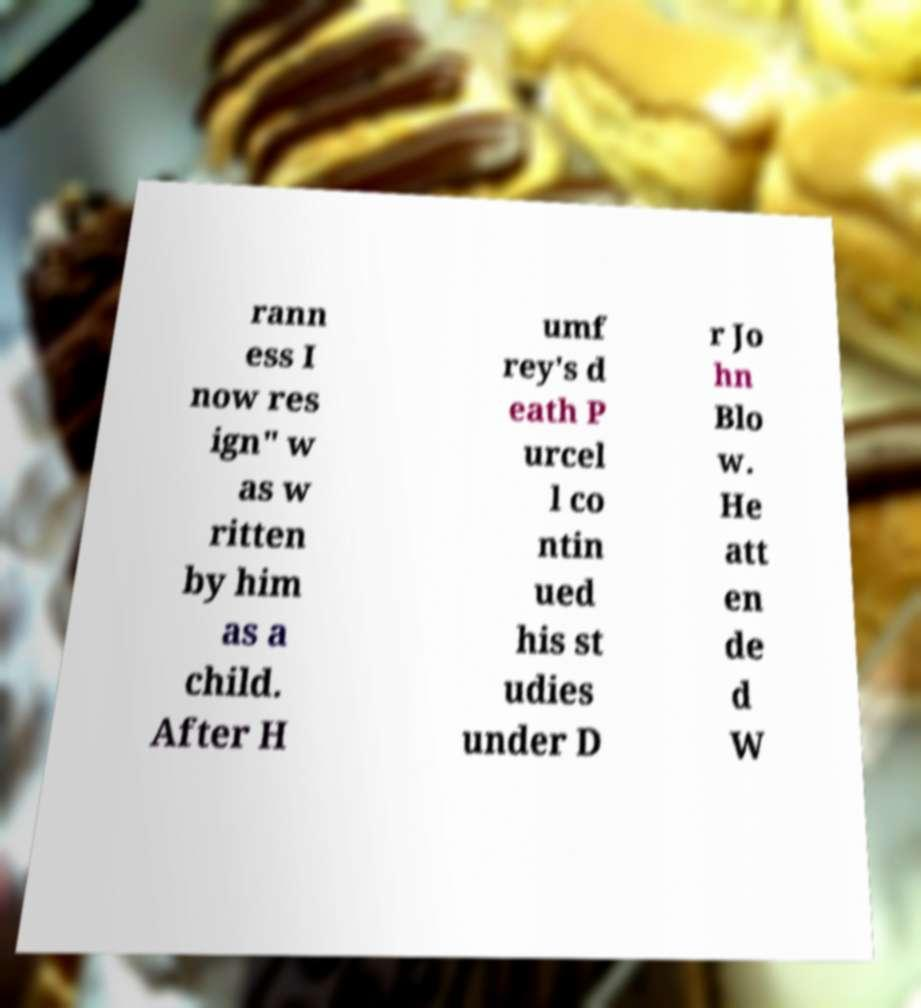Could you assist in decoding the text presented in this image and type it out clearly? rann ess I now res ign" w as w ritten by him as a child. After H umf rey's d eath P urcel l co ntin ued his st udies under D r Jo hn Blo w. He att en de d W 